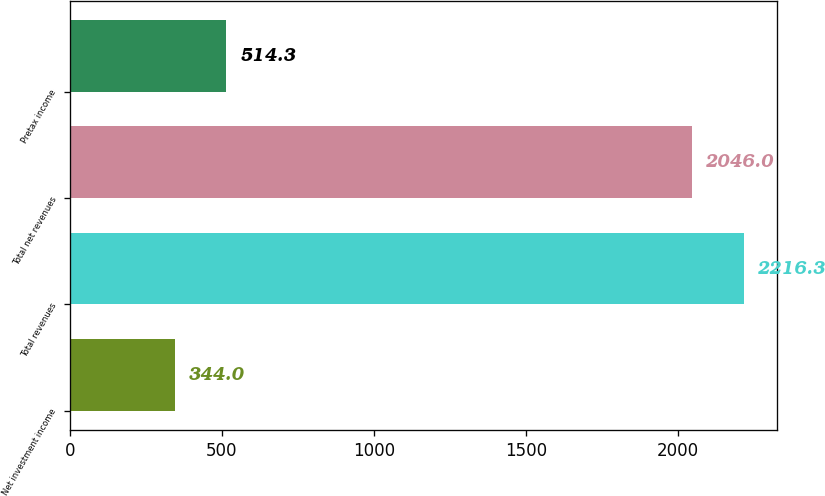<chart> <loc_0><loc_0><loc_500><loc_500><bar_chart><fcel>Net investment income<fcel>Total revenues<fcel>Total net revenues<fcel>Pretax income<nl><fcel>344<fcel>2216.3<fcel>2046<fcel>514.3<nl></chart> 